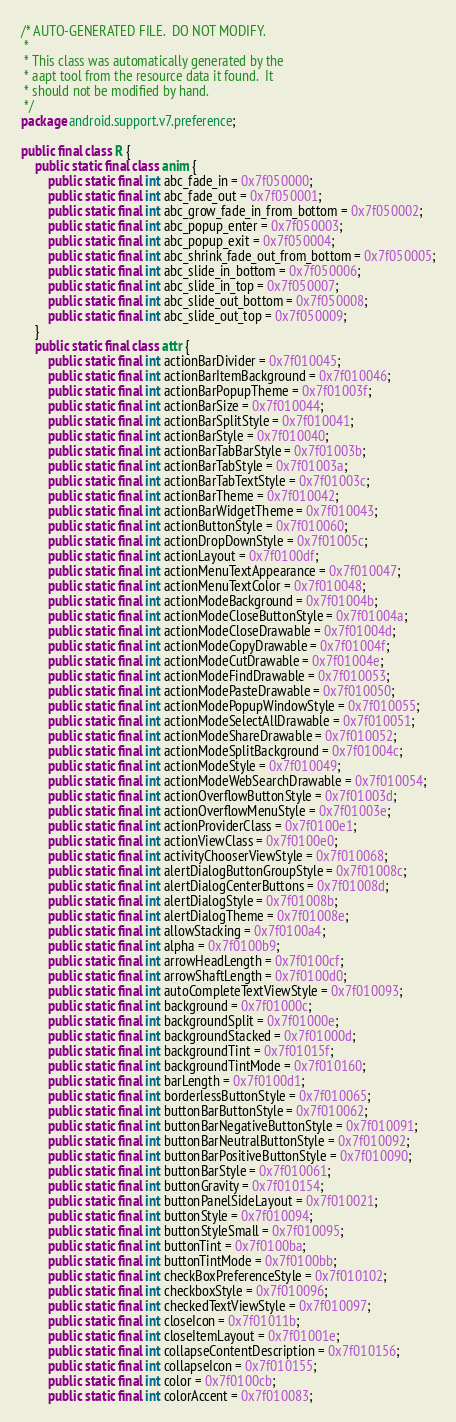Convert code to text. <code><loc_0><loc_0><loc_500><loc_500><_Java_>/* AUTO-GENERATED FILE.  DO NOT MODIFY.
 *
 * This class was automatically generated by the
 * aapt tool from the resource data it found.  It
 * should not be modified by hand.
 */
package android.support.v7.preference;

public final class R {
	public static final class anim {
		public static final int abc_fade_in = 0x7f050000;
		public static final int abc_fade_out = 0x7f050001;
		public static final int abc_grow_fade_in_from_bottom = 0x7f050002;
		public static final int abc_popup_enter = 0x7f050003;
		public static final int abc_popup_exit = 0x7f050004;
		public static final int abc_shrink_fade_out_from_bottom = 0x7f050005;
		public static final int abc_slide_in_bottom = 0x7f050006;
		public static final int abc_slide_in_top = 0x7f050007;
		public static final int abc_slide_out_bottom = 0x7f050008;
		public static final int abc_slide_out_top = 0x7f050009;
	}
	public static final class attr {
		public static final int actionBarDivider = 0x7f010045;
		public static final int actionBarItemBackground = 0x7f010046;
		public static final int actionBarPopupTheme = 0x7f01003f;
		public static final int actionBarSize = 0x7f010044;
		public static final int actionBarSplitStyle = 0x7f010041;
		public static final int actionBarStyle = 0x7f010040;
		public static final int actionBarTabBarStyle = 0x7f01003b;
		public static final int actionBarTabStyle = 0x7f01003a;
		public static final int actionBarTabTextStyle = 0x7f01003c;
		public static final int actionBarTheme = 0x7f010042;
		public static final int actionBarWidgetTheme = 0x7f010043;
		public static final int actionButtonStyle = 0x7f010060;
		public static final int actionDropDownStyle = 0x7f01005c;
		public static final int actionLayout = 0x7f0100df;
		public static final int actionMenuTextAppearance = 0x7f010047;
		public static final int actionMenuTextColor = 0x7f010048;
		public static final int actionModeBackground = 0x7f01004b;
		public static final int actionModeCloseButtonStyle = 0x7f01004a;
		public static final int actionModeCloseDrawable = 0x7f01004d;
		public static final int actionModeCopyDrawable = 0x7f01004f;
		public static final int actionModeCutDrawable = 0x7f01004e;
		public static final int actionModeFindDrawable = 0x7f010053;
		public static final int actionModePasteDrawable = 0x7f010050;
		public static final int actionModePopupWindowStyle = 0x7f010055;
		public static final int actionModeSelectAllDrawable = 0x7f010051;
		public static final int actionModeShareDrawable = 0x7f010052;
		public static final int actionModeSplitBackground = 0x7f01004c;
		public static final int actionModeStyle = 0x7f010049;
		public static final int actionModeWebSearchDrawable = 0x7f010054;
		public static final int actionOverflowButtonStyle = 0x7f01003d;
		public static final int actionOverflowMenuStyle = 0x7f01003e;
		public static final int actionProviderClass = 0x7f0100e1;
		public static final int actionViewClass = 0x7f0100e0;
		public static final int activityChooserViewStyle = 0x7f010068;
		public static final int alertDialogButtonGroupStyle = 0x7f01008c;
		public static final int alertDialogCenterButtons = 0x7f01008d;
		public static final int alertDialogStyle = 0x7f01008b;
		public static final int alertDialogTheme = 0x7f01008e;
		public static final int allowStacking = 0x7f0100a4;
		public static final int alpha = 0x7f0100b9;
		public static final int arrowHeadLength = 0x7f0100cf;
		public static final int arrowShaftLength = 0x7f0100d0;
		public static final int autoCompleteTextViewStyle = 0x7f010093;
		public static final int background = 0x7f01000c;
		public static final int backgroundSplit = 0x7f01000e;
		public static final int backgroundStacked = 0x7f01000d;
		public static final int backgroundTint = 0x7f01015f;
		public static final int backgroundTintMode = 0x7f010160;
		public static final int barLength = 0x7f0100d1;
		public static final int borderlessButtonStyle = 0x7f010065;
		public static final int buttonBarButtonStyle = 0x7f010062;
		public static final int buttonBarNegativeButtonStyle = 0x7f010091;
		public static final int buttonBarNeutralButtonStyle = 0x7f010092;
		public static final int buttonBarPositiveButtonStyle = 0x7f010090;
		public static final int buttonBarStyle = 0x7f010061;
		public static final int buttonGravity = 0x7f010154;
		public static final int buttonPanelSideLayout = 0x7f010021;
		public static final int buttonStyle = 0x7f010094;
		public static final int buttonStyleSmall = 0x7f010095;
		public static final int buttonTint = 0x7f0100ba;
		public static final int buttonTintMode = 0x7f0100bb;
		public static final int checkBoxPreferenceStyle = 0x7f010102;
		public static final int checkboxStyle = 0x7f010096;
		public static final int checkedTextViewStyle = 0x7f010097;
		public static final int closeIcon = 0x7f01011b;
		public static final int closeItemLayout = 0x7f01001e;
		public static final int collapseContentDescription = 0x7f010156;
		public static final int collapseIcon = 0x7f010155;
		public static final int color = 0x7f0100cb;
		public static final int colorAccent = 0x7f010083;</code> 